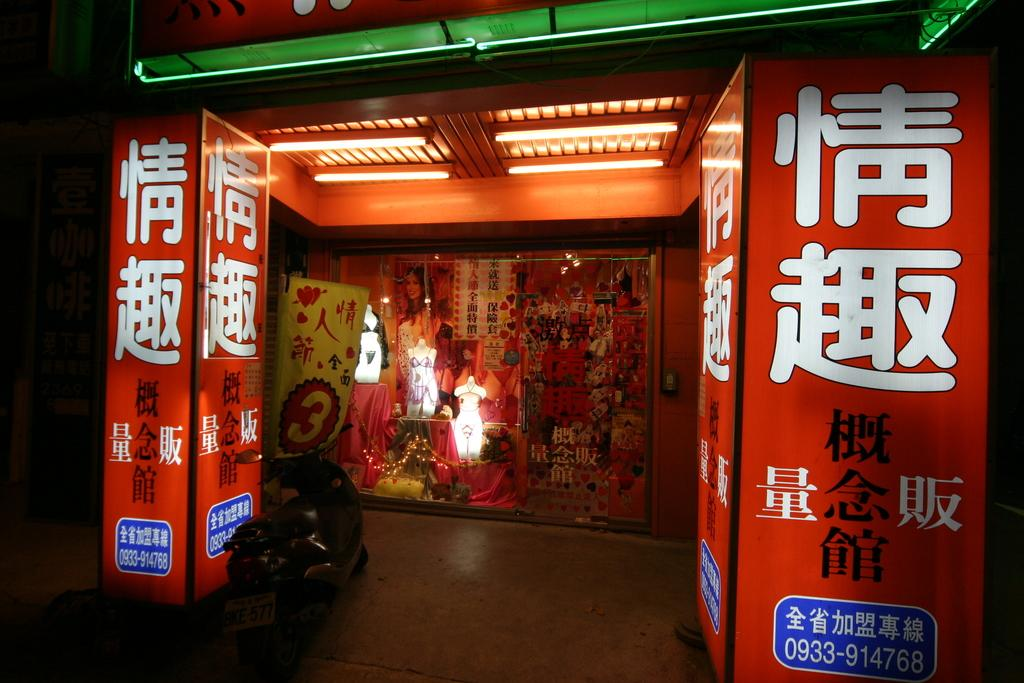What can be seen in the foreground of the picture? There are banners and a motorbike in the foreground of the picture. What is located in the center of the picture? There is a glass window in the center of the picture, and many objects are visible there. What type of humor can be seen in the vase in the center of the picture? There is no vase present in the image, and therefore no humor can be seen in it. 